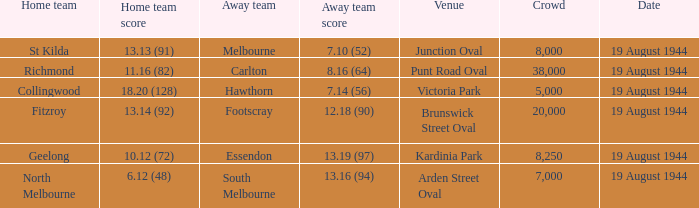What is Fitzroy's Home team score? 13.14 (92). 